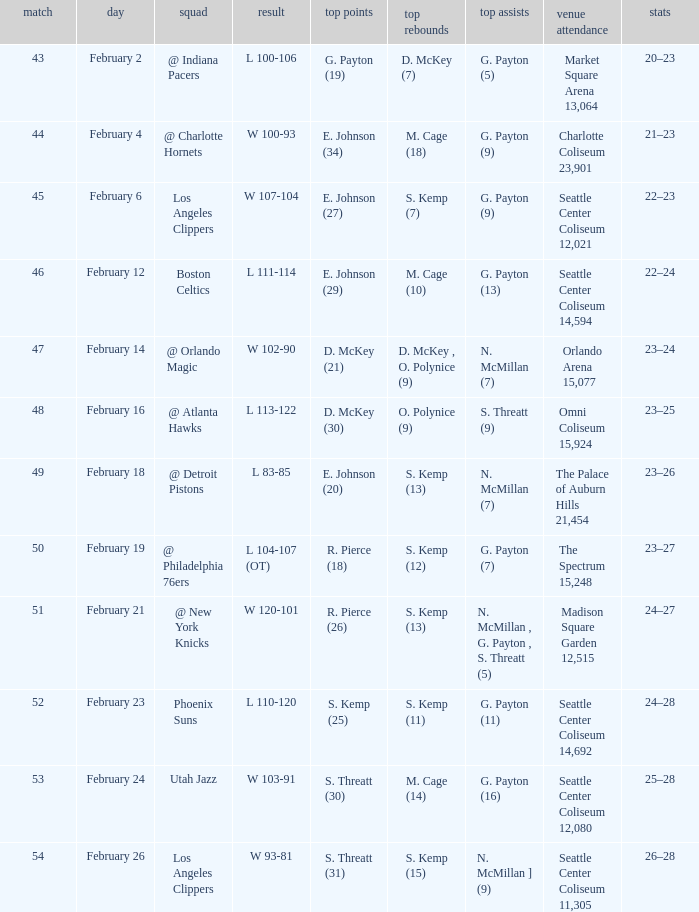What is the record for the Utah Jazz? 25–28. 